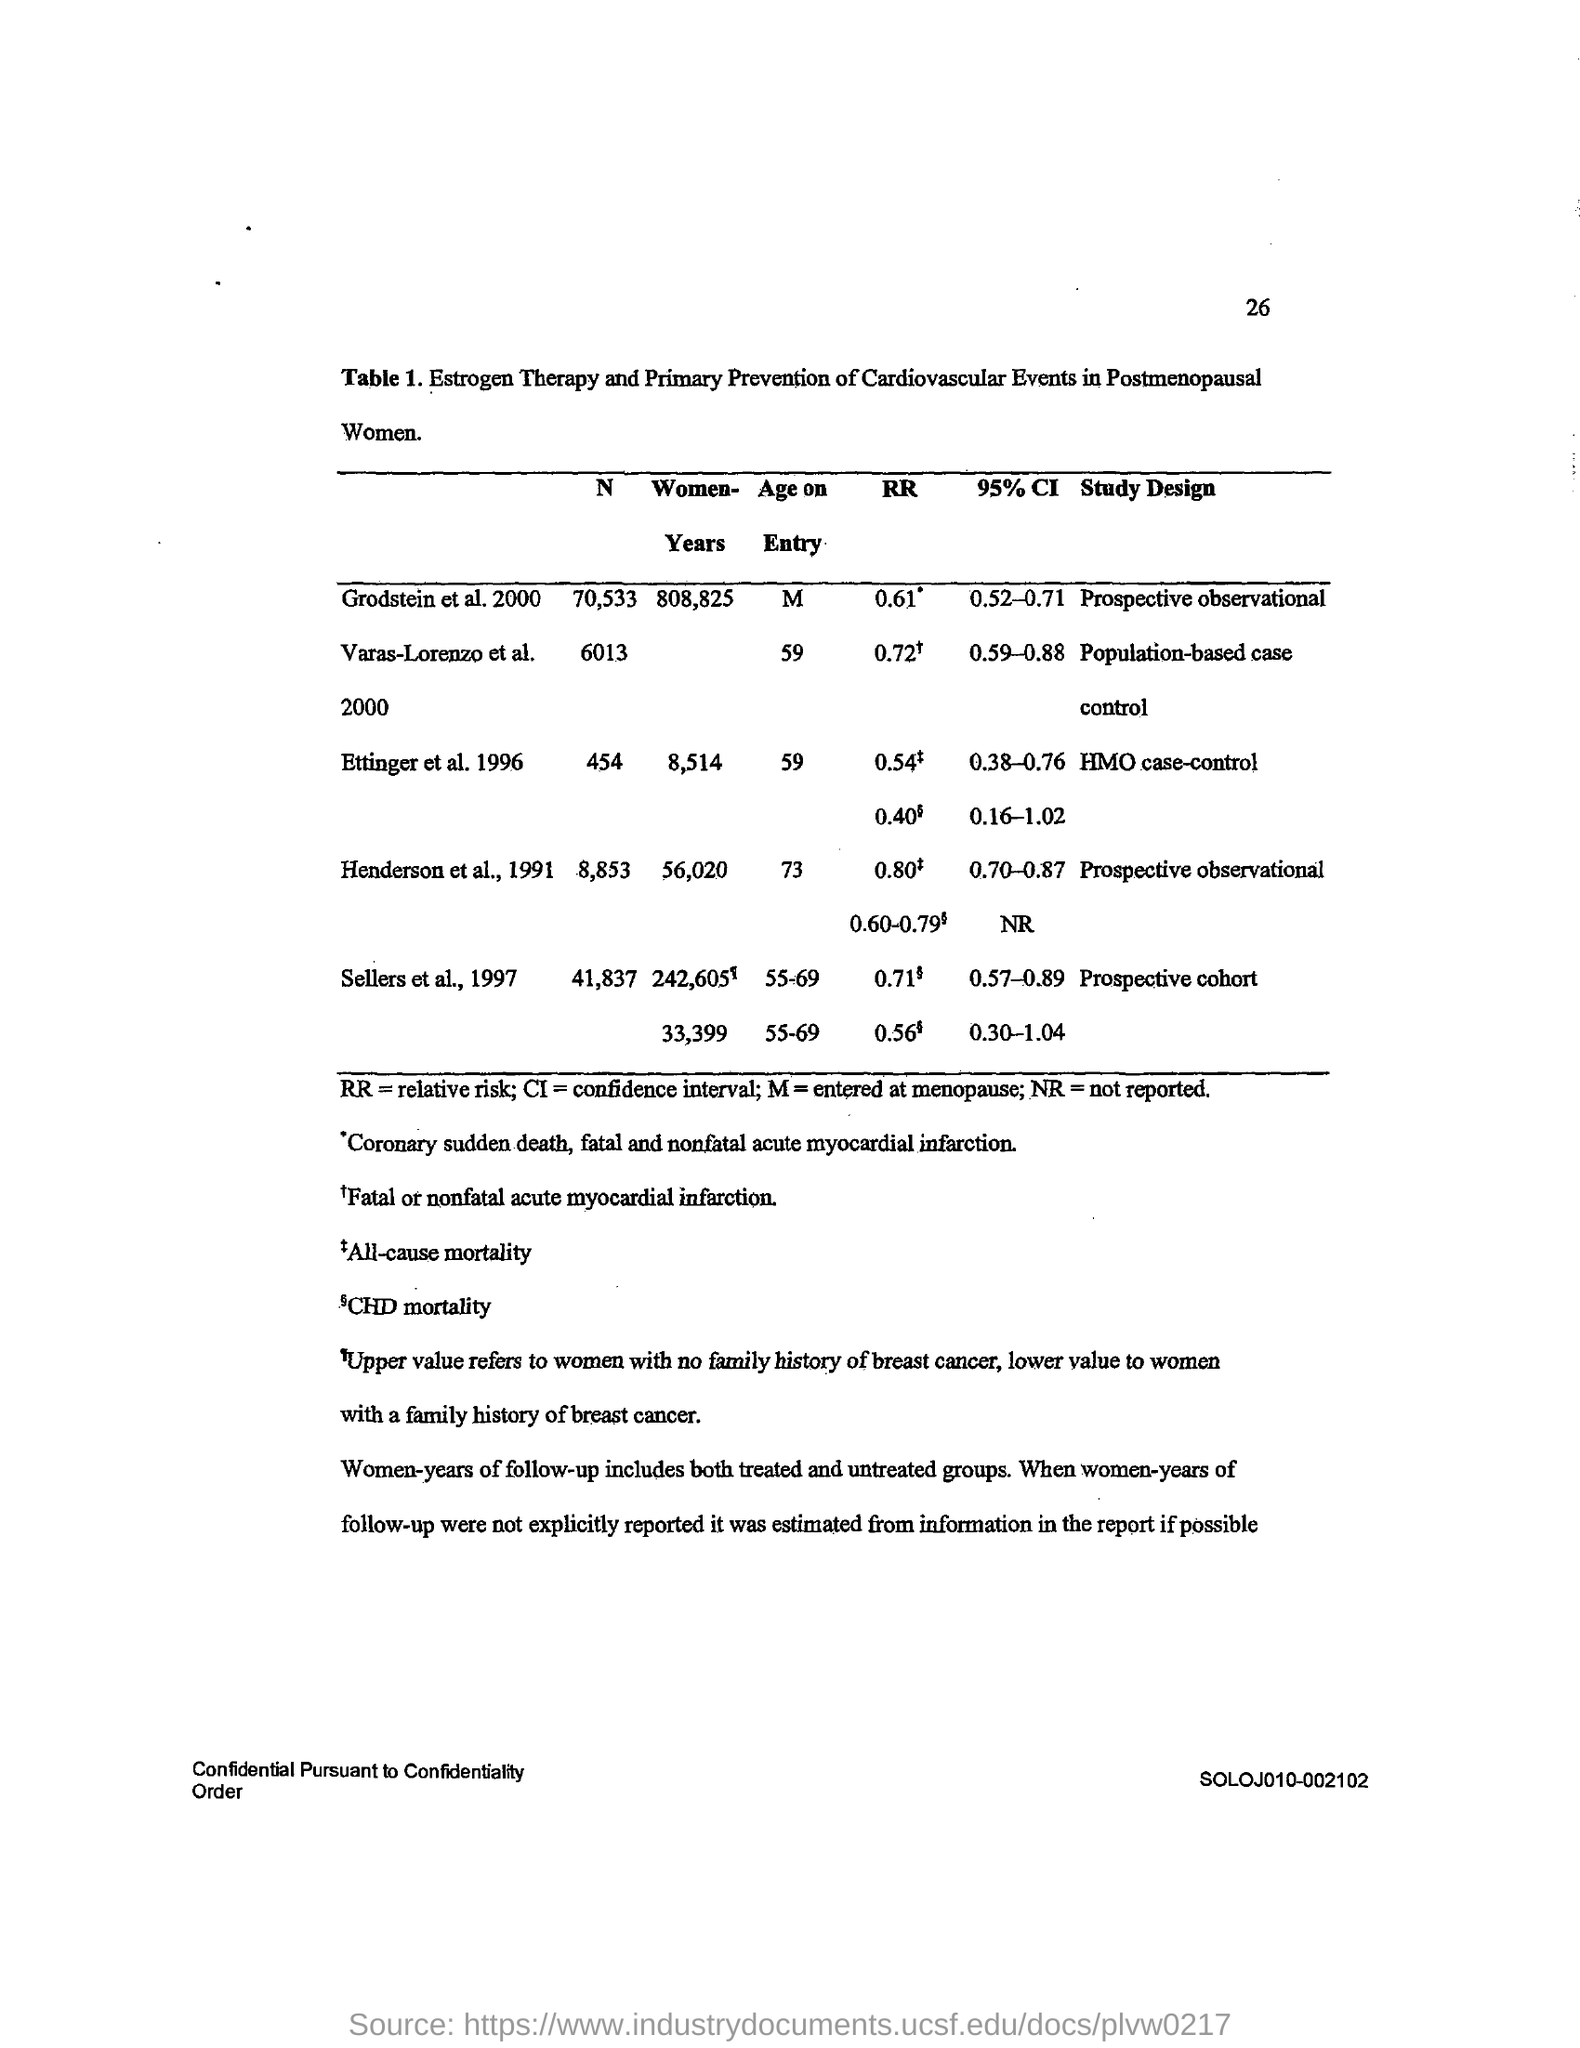Specify some key components in this picture. Relative risk" is a term used in epidemiology and public health to describe the ratio of the incidence or prevalence of a disease or outcome in an exposed group to the incidence or prevalence in a non-exposed group, adjusted for other factors that may influence the outcome. Confidence interval is a statistical term that refers to a range of values that is calculated based on a sample of data, with a certain level of confidence. It provides an estimate of the true population value and is used to make inferences about the population based on the sample data. 